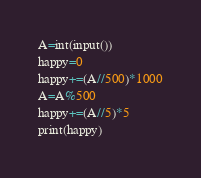<code> <loc_0><loc_0><loc_500><loc_500><_Python_>A=int(input())
happy=0
happy+=(A//500)*1000
A=A%500
happy+=(A//5)*5
print(happy)
</code> 